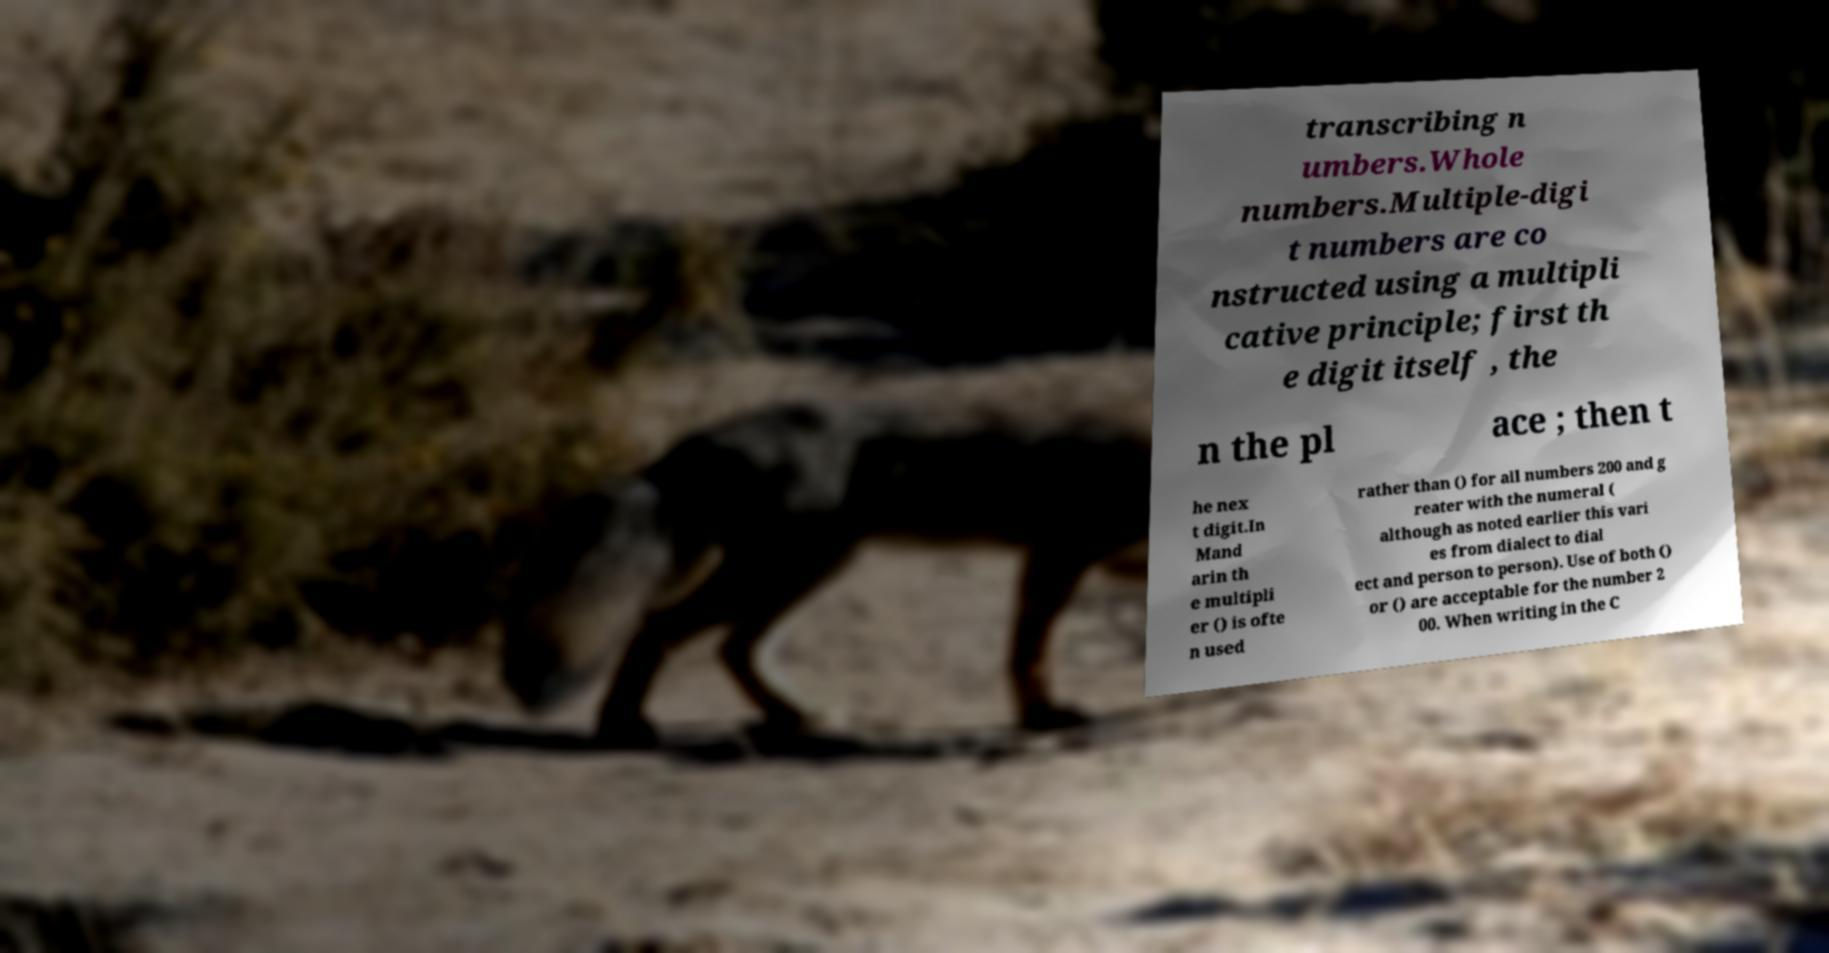Please identify and transcribe the text found in this image. transcribing n umbers.Whole numbers.Multiple-digi t numbers are co nstructed using a multipli cative principle; first th e digit itself , the n the pl ace ; then t he nex t digit.In Mand arin th e multipli er () is ofte n used rather than () for all numbers 200 and g reater with the numeral ( although as noted earlier this vari es from dialect to dial ect and person to person). Use of both () or () are acceptable for the number 2 00. When writing in the C 